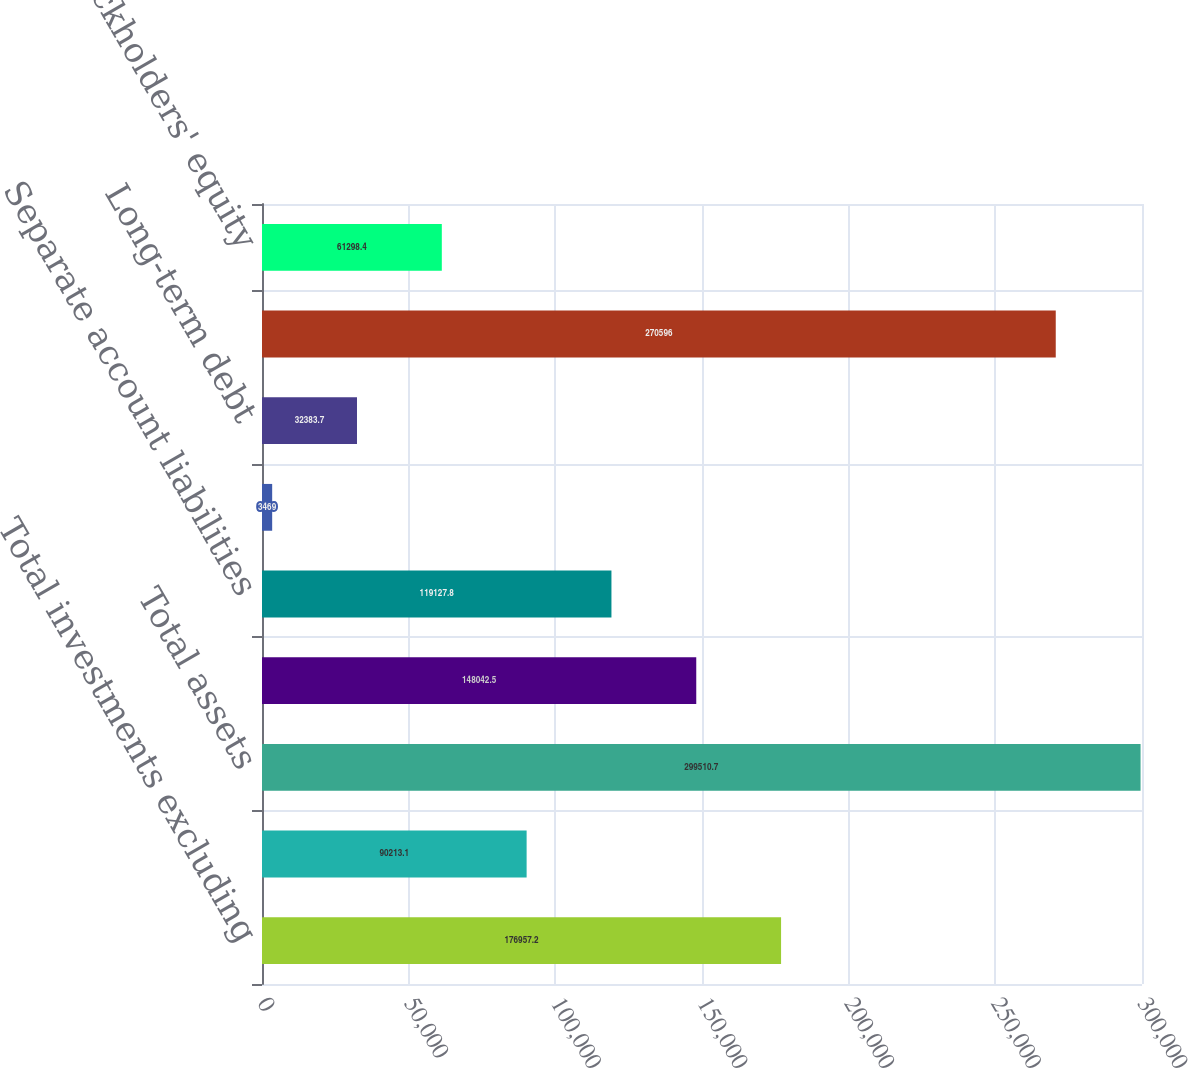<chart> <loc_0><loc_0><loc_500><loc_500><bar_chart><fcel>Total investments excluding<fcel>Separate account assets<fcel>Total assets<fcel>Future policy benefits and<fcel>Separate account liabilities<fcel>Short-term debt<fcel>Long-term debt<fcel>Total liabilities<fcel>Stockholders' equity<nl><fcel>176957<fcel>90213.1<fcel>299511<fcel>148042<fcel>119128<fcel>3469<fcel>32383.7<fcel>270596<fcel>61298.4<nl></chart> 